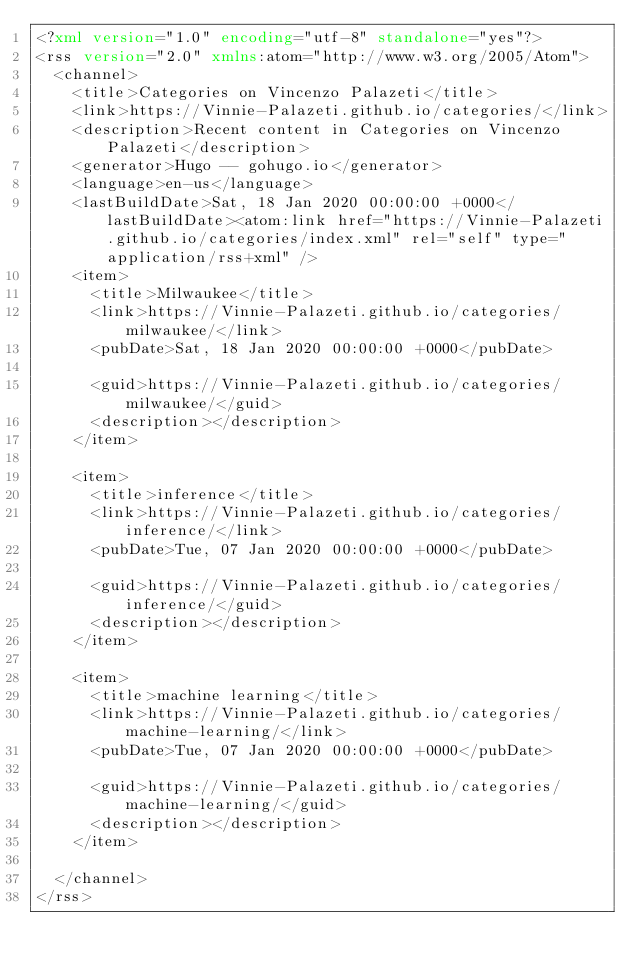Convert code to text. <code><loc_0><loc_0><loc_500><loc_500><_XML_><?xml version="1.0" encoding="utf-8" standalone="yes"?>
<rss version="2.0" xmlns:atom="http://www.w3.org/2005/Atom">
  <channel>
    <title>Categories on Vincenzo Palazeti</title>
    <link>https://Vinnie-Palazeti.github.io/categories/</link>
    <description>Recent content in Categories on Vincenzo Palazeti</description>
    <generator>Hugo -- gohugo.io</generator>
    <language>en-us</language>
    <lastBuildDate>Sat, 18 Jan 2020 00:00:00 +0000</lastBuildDate><atom:link href="https://Vinnie-Palazeti.github.io/categories/index.xml" rel="self" type="application/rss+xml" />
    <item>
      <title>Milwaukee</title>
      <link>https://Vinnie-Palazeti.github.io/categories/milwaukee/</link>
      <pubDate>Sat, 18 Jan 2020 00:00:00 +0000</pubDate>
      
      <guid>https://Vinnie-Palazeti.github.io/categories/milwaukee/</guid>
      <description></description>
    </item>
    
    <item>
      <title>inference</title>
      <link>https://Vinnie-Palazeti.github.io/categories/inference/</link>
      <pubDate>Tue, 07 Jan 2020 00:00:00 +0000</pubDate>
      
      <guid>https://Vinnie-Palazeti.github.io/categories/inference/</guid>
      <description></description>
    </item>
    
    <item>
      <title>machine learning</title>
      <link>https://Vinnie-Palazeti.github.io/categories/machine-learning/</link>
      <pubDate>Tue, 07 Jan 2020 00:00:00 +0000</pubDate>
      
      <guid>https://Vinnie-Palazeti.github.io/categories/machine-learning/</guid>
      <description></description>
    </item>
    
  </channel>
</rss>
</code> 